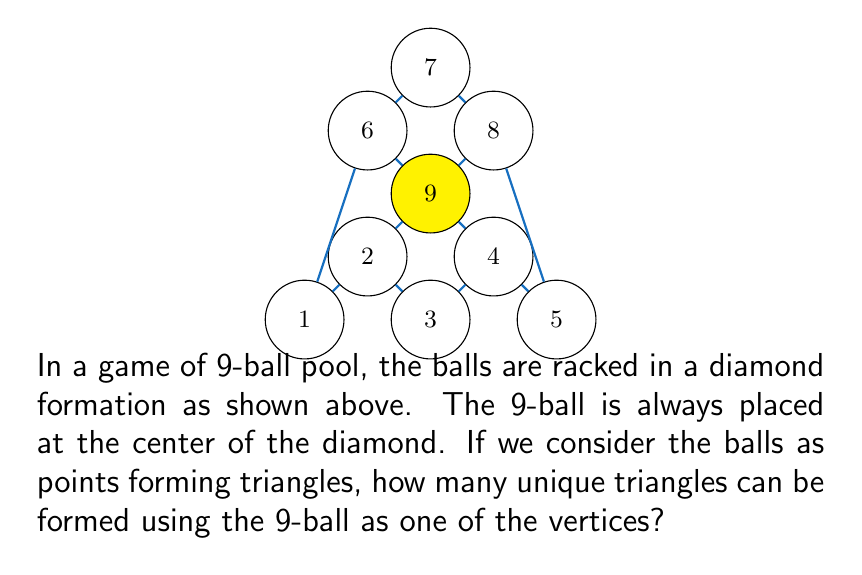Teach me how to tackle this problem. Let's approach this problem step-by-step:

1) First, we need to identify the position of the 9-ball. In this rack, the 9-ball is at the center (yellow in the diagram).

2) To form a triangle, we need to choose 2 other balls in addition to the 9-ball.

3) The total number of balls excluding the 9-ball is 8.

4) This is a combination problem. We need to calculate how many ways we can choose 2 balls from 8 balls.

5) The formula for this combination is:

   $$C(8,2) = \frac{8!}{2!(8-2)!} = \frac{8!}{2!(6)!}$$

6) Let's calculate this:
   $$\frac{8 \times 7}{2 \times 1} = \frac{56}{2} = 28$$

7) Therefore, there are 28 unique ways to choose 2 balls from the remaining 8 balls.

8) Each of these combinations, when paired with the 9-ball, forms a unique triangle.

Thus, 28 unique triangles can be formed using the 9-ball as one of the vertices.
Answer: 28 